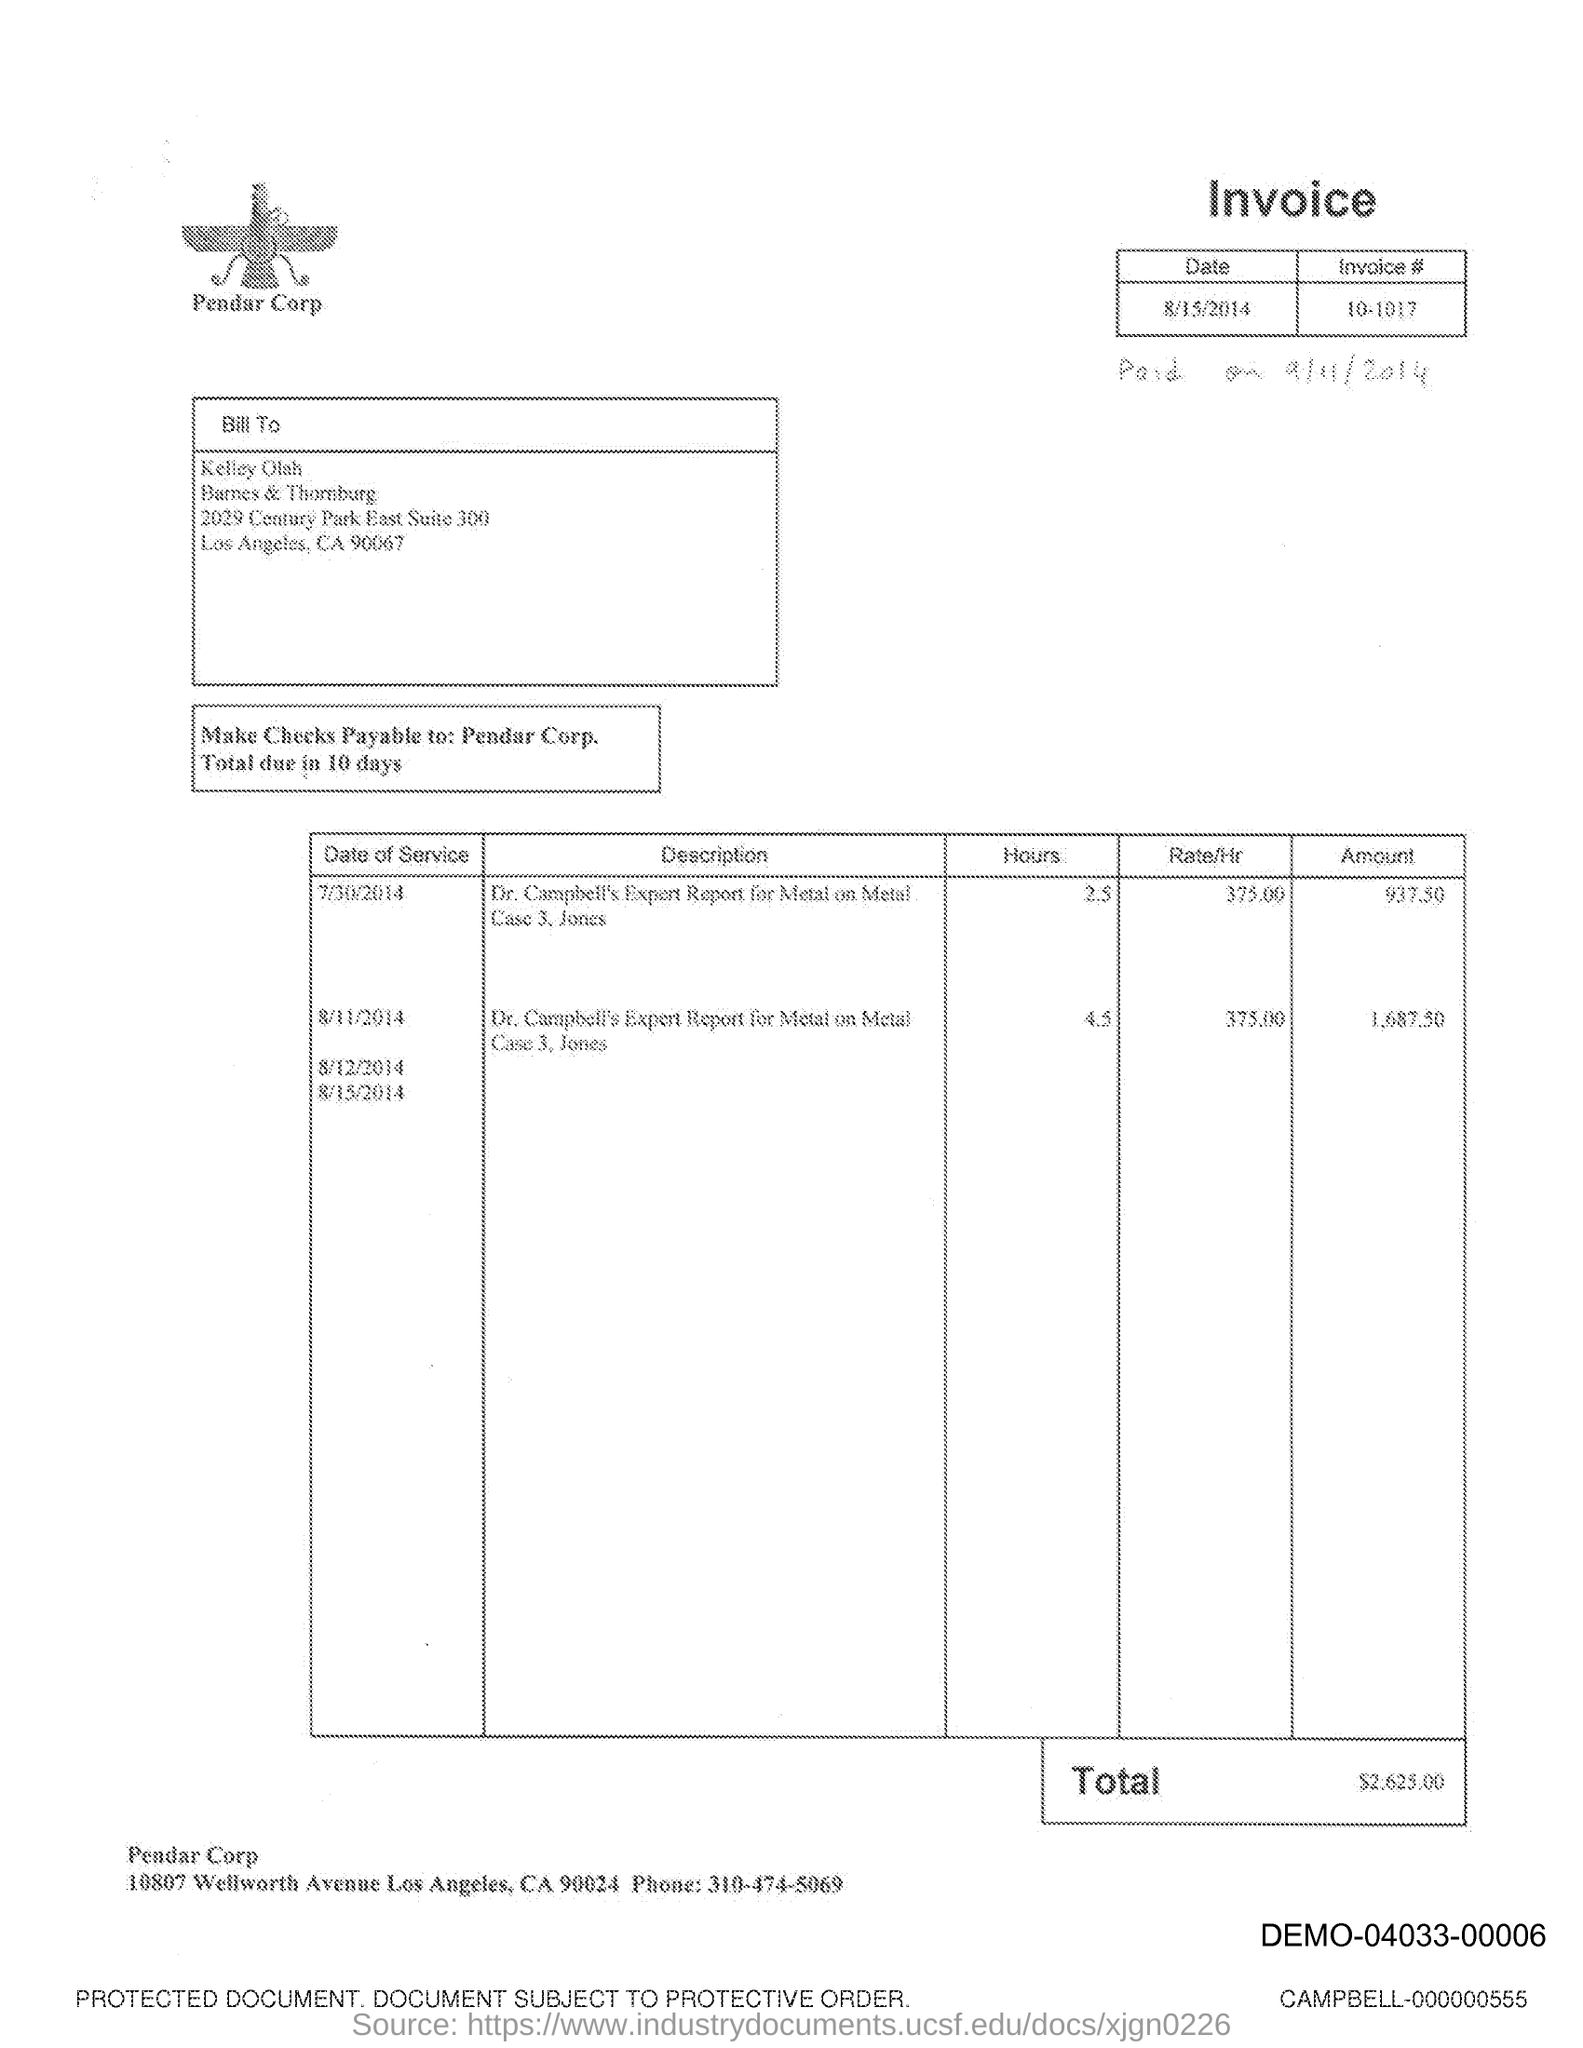Highlight a few significant elements in this photo. The invoice number is 10-1017. The phone number mentioned is 310-474-5069. The date of the invoice is August 15, 2014. The bill is addressed to Kelley Olah. The total invoice amount is 2,625.00. 